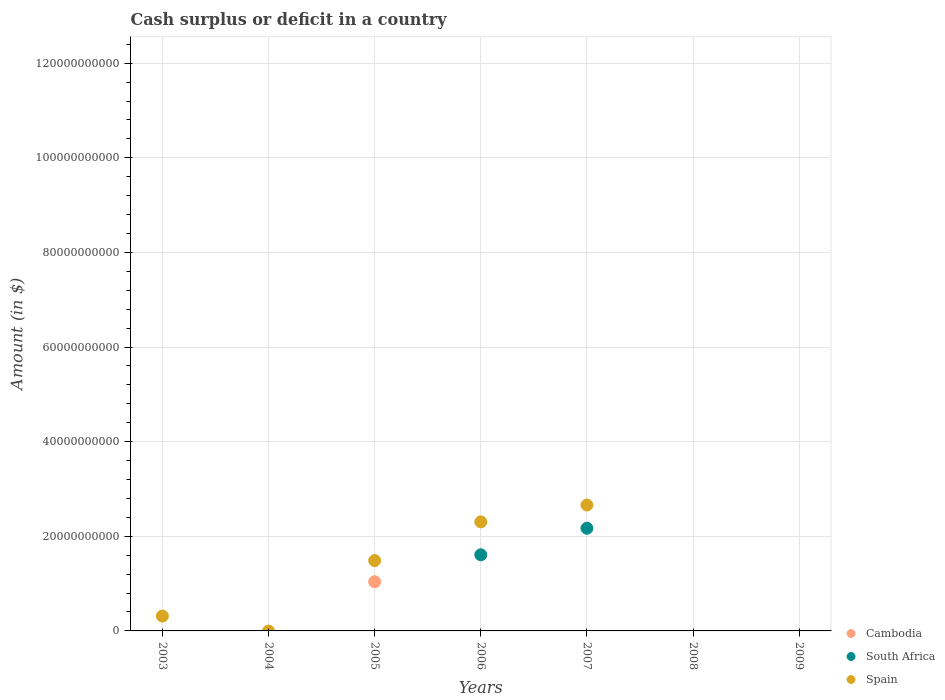What is the amount of cash surplus or deficit in South Africa in 2008?
Keep it short and to the point. 0. Across all years, what is the maximum amount of cash surplus or deficit in Cambodia?
Make the answer very short. 1.04e+1. In which year was the amount of cash surplus or deficit in South Africa maximum?
Make the answer very short. 2007. What is the total amount of cash surplus or deficit in Spain in the graph?
Keep it short and to the point. 6.77e+1. What is the difference between the amount of cash surplus or deficit in Spain in 2003 and that in 2005?
Make the answer very short. -1.17e+1. What is the difference between the amount of cash surplus or deficit in Spain in 2007 and the amount of cash surplus or deficit in South Africa in 2008?
Your answer should be compact. 2.66e+1. What is the average amount of cash surplus or deficit in Cambodia per year?
Your answer should be compact. 1.48e+09. In the year 2005, what is the difference between the amount of cash surplus or deficit in Cambodia and amount of cash surplus or deficit in Spain?
Your answer should be very brief. -4.47e+09. What is the ratio of the amount of cash surplus or deficit in South Africa in 2006 to that in 2007?
Make the answer very short. 0.74. What is the difference between the highest and the lowest amount of cash surplus or deficit in Spain?
Give a very brief answer. 2.66e+1. In how many years, is the amount of cash surplus or deficit in South Africa greater than the average amount of cash surplus or deficit in South Africa taken over all years?
Keep it short and to the point. 2. Is the sum of the amount of cash surplus or deficit in South Africa in 2006 and 2007 greater than the maximum amount of cash surplus or deficit in Spain across all years?
Your answer should be very brief. Yes. Is the amount of cash surplus or deficit in South Africa strictly less than the amount of cash surplus or deficit in Spain over the years?
Provide a short and direct response. No. How many dotlines are there?
Your answer should be compact. 3. Does the graph contain grids?
Make the answer very short. Yes. Where does the legend appear in the graph?
Give a very brief answer. Bottom right. How are the legend labels stacked?
Keep it short and to the point. Vertical. What is the title of the graph?
Your answer should be very brief. Cash surplus or deficit in a country. Does "Grenada" appear as one of the legend labels in the graph?
Offer a terse response. No. What is the label or title of the Y-axis?
Make the answer very short. Amount (in $). What is the Amount (in $) in Cambodia in 2003?
Keep it short and to the point. 0. What is the Amount (in $) of Spain in 2003?
Your response must be concise. 3.14e+09. What is the Amount (in $) of Cambodia in 2005?
Ensure brevity in your answer.  1.04e+1. What is the Amount (in $) in South Africa in 2005?
Your answer should be very brief. 0. What is the Amount (in $) of Spain in 2005?
Your answer should be very brief. 1.49e+1. What is the Amount (in $) in South Africa in 2006?
Keep it short and to the point. 1.61e+1. What is the Amount (in $) in Spain in 2006?
Offer a very short reply. 2.30e+1. What is the Amount (in $) of Cambodia in 2007?
Ensure brevity in your answer.  0. What is the Amount (in $) of South Africa in 2007?
Give a very brief answer. 2.17e+1. What is the Amount (in $) in Spain in 2007?
Your answer should be compact. 2.66e+1. What is the Amount (in $) of Cambodia in 2008?
Provide a short and direct response. 0. What is the Amount (in $) in South Africa in 2008?
Provide a succinct answer. 0. What is the Amount (in $) of Cambodia in 2009?
Provide a short and direct response. 0. What is the Amount (in $) in South Africa in 2009?
Offer a terse response. 0. What is the Amount (in $) in Spain in 2009?
Give a very brief answer. 0. Across all years, what is the maximum Amount (in $) of Cambodia?
Ensure brevity in your answer.  1.04e+1. Across all years, what is the maximum Amount (in $) in South Africa?
Your answer should be compact. 2.17e+1. Across all years, what is the maximum Amount (in $) in Spain?
Your answer should be compact. 2.66e+1. Across all years, what is the minimum Amount (in $) of Cambodia?
Keep it short and to the point. 0. Across all years, what is the minimum Amount (in $) in South Africa?
Give a very brief answer. 0. What is the total Amount (in $) of Cambodia in the graph?
Give a very brief answer. 1.04e+1. What is the total Amount (in $) of South Africa in the graph?
Keep it short and to the point. 3.78e+1. What is the total Amount (in $) of Spain in the graph?
Keep it short and to the point. 6.77e+1. What is the difference between the Amount (in $) in Spain in 2003 and that in 2005?
Offer a terse response. -1.17e+1. What is the difference between the Amount (in $) of Spain in 2003 and that in 2006?
Give a very brief answer. -1.99e+1. What is the difference between the Amount (in $) of Spain in 2003 and that in 2007?
Your answer should be very brief. -2.35e+1. What is the difference between the Amount (in $) in Spain in 2005 and that in 2006?
Make the answer very short. -8.18e+09. What is the difference between the Amount (in $) in Spain in 2005 and that in 2007?
Offer a terse response. -1.17e+1. What is the difference between the Amount (in $) of South Africa in 2006 and that in 2007?
Keep it short and to the point. -5.61e+09. What is the difference between the Amount (in $) in Spain in 2006 and that in 2007?
Your answer should be compact. -3.56e+09. What is the difference between the Amount (in $) of Cambodia in 2005 and the Amount (in $) of South Africa in 2006?
Offer a terse response. -5.69e+09. What is the difference between the Amount (in $) in Cambodia in 2005 and the Amount (in $) in Spain in 2006?
Provide a succinct answer. -1.27e+1. What is the difference between the Amount (in $) in Cambodia in 2005 and the Amount (in $) in South Africa in 2007?
Offer a terse response. -1.13e+1. What is the difference between the Amount (in $) of Cambodia in 2005 and the Amount (in $) of Spain in 2007?
Ensure brevity in your answer.  -1.62e+1. What is the difference between the Amount (in $) in South Africa in 2006 and the Amount (in $) in Spain in 2007?
Keep it short and to the point. -1.05e+1. What is the average Amount (in $) of Cambodia per year?
Your response must be concise. 1.48e+09. What is the average Amount (in $) of South Africa per year?
Ensure brevity in your answer.  5.40e+09. What is the average Amount (in $) of Spain per year?
Offer a terse response. 9.67e+09. In the year 2005, what is the difference between the Amount (in $) of Cambodia and Amount (in $) of Spain?
Give a very brief answer. -4.47e+09. In the year 2006, what is the difference between the Amount (in $) in South Africa and Amount (in $) in Spain?
Provide a short and direct response. -6.96e+09. In the year 2007, what is the difference between the Amount (in $) in South Africa and Amount (in $) in Spain?
Keep it short and to the point. -4.91e+09. What is the ratio of the Amount (in $) in Spain in 2003 to that in 2005?
Your answer should be very brief. 0.21. What is the ratio of the Amount (in $) of Spain in 2003 to that in 2006?
Make the answer very short. 0.14. What is the ratio of the Amount (in $) of Spain in 2003 to that in 2007?
Offer a terse response. 0.12. What is the ratio of the Amount (in $) of Spain in 2005 to that in 2006?
Provide a succinct answer. 0.64. What is the ratio of the Amount (in $) of Spain in 2005 to that in 2007?
Your response must be concise. 0.56. What is the ratio of the Amount (in $) of South Africa in 2006 to that in 2007?
Offer a very short reply. 0.74. What is the ratio of the Amount (in $) in Spain in 2006 to that in 2007?
Make the answer very short. 0.87. What is the difference between the highest and the second highest Amount (in $) in Spain?
Your answer should be very brief. 3.56e+09. What is the difference between the highest and the lowest Amount (in $) of Cambodia?
Offer a terse response. 1.04e+1. What is the difference between the highest and the lowest Amount (in $) of South Africa?
Make the answer very short. 2.17e+1. What is the difference between the highest and the lowest Amount (in $) of Spain?
Your answer should be very brief. 2.66e+1. 